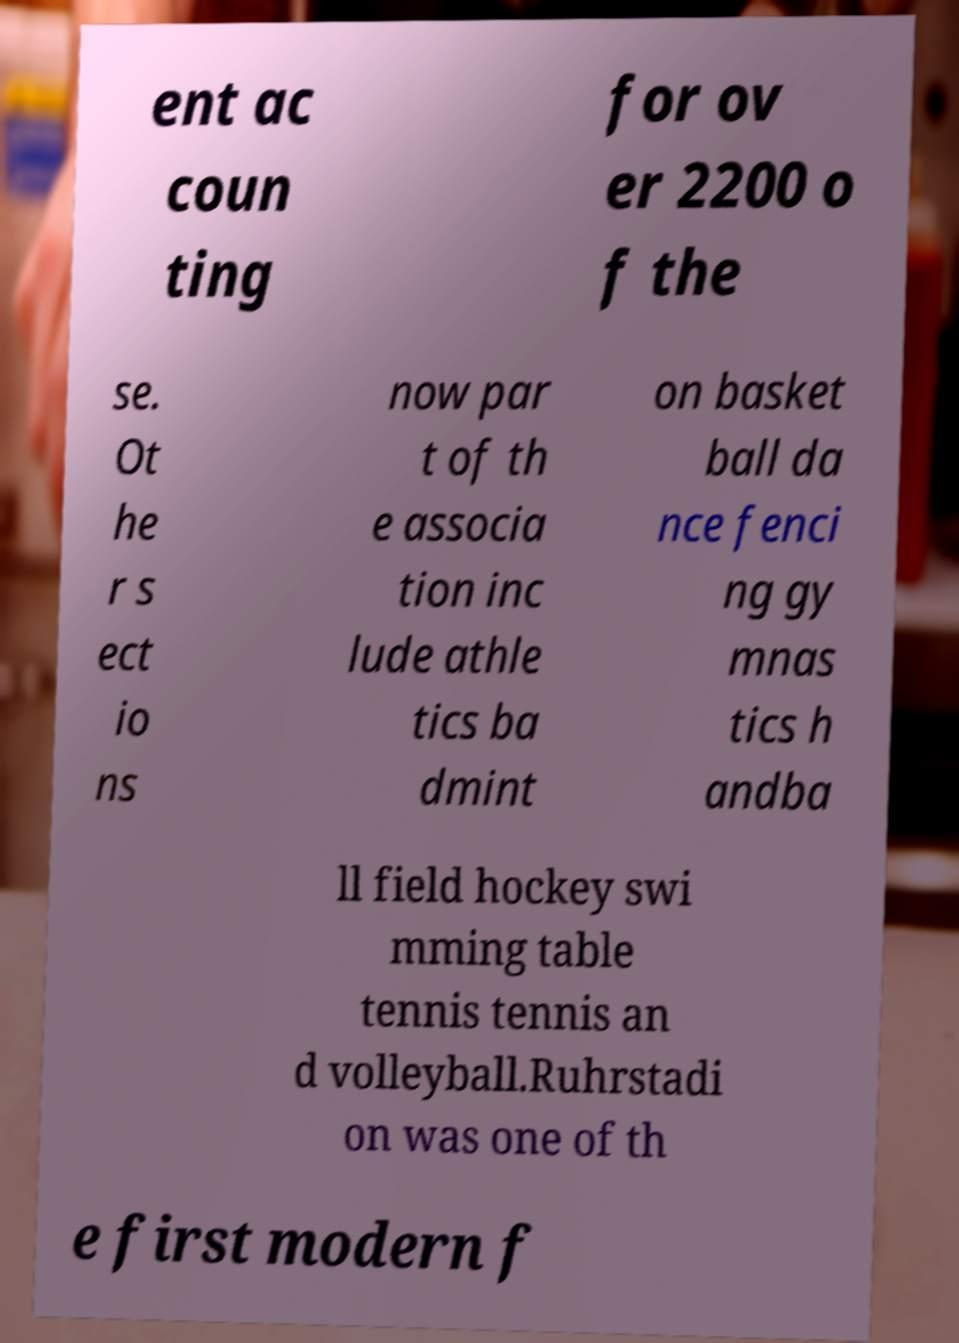Please read and relay the text visible in this image. What does it say? ent ac coun ting for ov er 2200 o f the se. Ot he r s ect io ns now par t of th e associa tion inc lude athle tics ba dmint on basket ball da nce fenci ng gy mnas tics h andba ll field hockey swi mming table tennis tennis an d volleyball.Ruhrstadi on was one of th e first modern f 